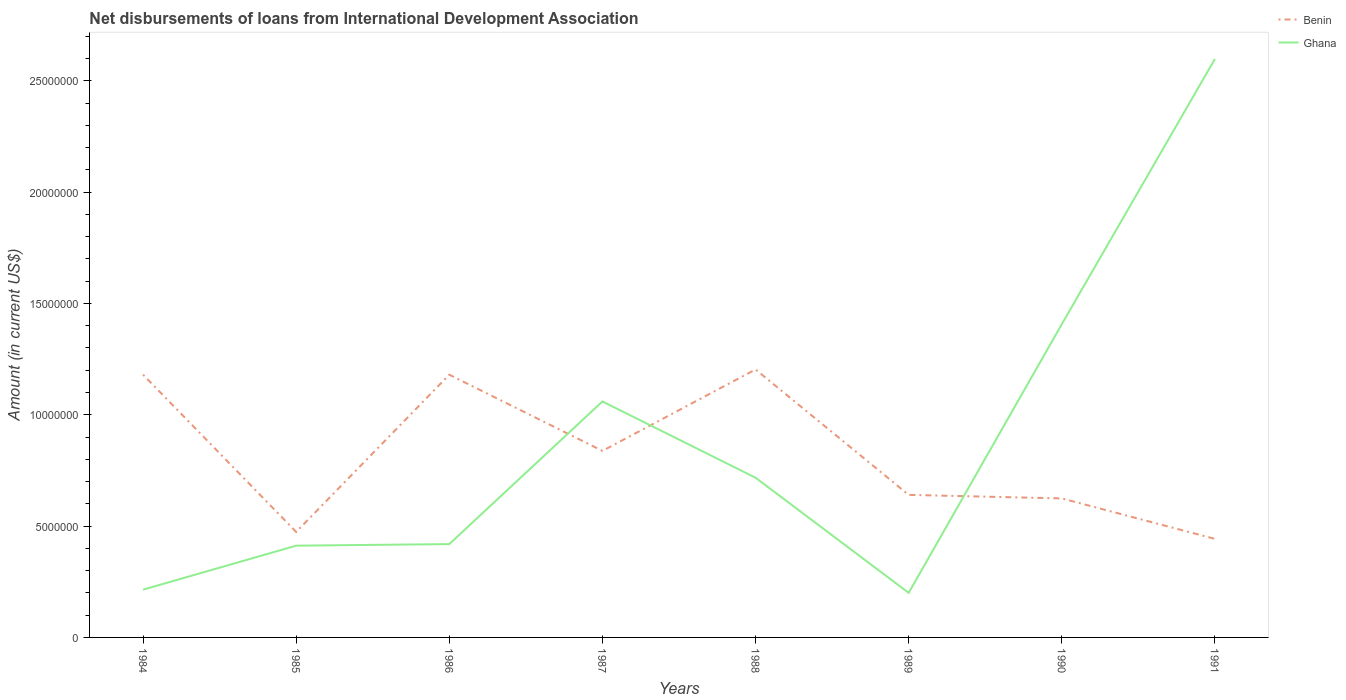Is the number of lines equal to the number of legend labels?
Your response must be concise. Yes. Across all years, what is the maximum amount of loans disbursed in Benin?
Offer a terse response. 4.43e+06. In which year was the amount of loans disbursed in Benin maximum?
Provide a short and direct response. 1991. What is the total amount of loans disbursed in Ghana in the graph?
Give a very brief answer. -1.19e+07. What is the difference between the highest and the second highest amount of loans disbursed in Ghana?
Offer a very short reply. 2.40e+07. What is the difference between the highest and the lowest amount of loans disbursed in Benin?
Keep it short and to the point. 4. Is the amount of loans disbursed in Benin strictly greater than the amount of loans disbursed in Ghana over the years?
Your answer should be compact. No. How many lines are there?
Ensure brevity in your answer.  2. How many years are there in the graph?
Your response must be concise. 8. Does the graph contain any zero values?
Offer a terse response. No. Does the graph contain grids?
Offer a terse response. No. How many legend labels are there?
Keep it short and to the point. 2. How are the legend labels stacked?
Provide a succinct answer. Vertical. What is the title of the graph?
Make the answer very short. Net disbursements of loans from International Development Association. What is the label or title of the X-axis?
Make the answer very short. Years. What is the label or title of the Y-axis?
Your answer should be very brief. Amount (in current US$). What is the Amount (in current US$) in Benin in 1984?
Ensure brevity in your answer.  1.18e+07. What is the Amount (in current US$) of Ghana in 1984?
Ensure brevity in your answer.  2.14e+06. What is the Amount (in current US$) of Benin in 1985?
Make the answer very short. 4.74e+06. What is the Amount (in current US$) of Ghana in 1985?
Make the answer very short. 4.12e+06. What is the Amount (in current US$) in Benin in 1986?
Provide a succinct answer. 1.18e+07. What is the Amount (in current US$) of Ghana in 1986?
Provide a succinct answer. 4.19e+06. What is the Amount (in current US$) of Benin in 1987?
Ensure brevity in your answer.  8.38e+06. What is the Amount (in current US$) in Ghana in 1987?
Make the answer very short. 1.06e+07. What is the Amount (in current US$) of Benin in 1988?
Your answer should be very brief. 1.20e+07. What is the Amount (in current US$) of Ghana in 1988?
Offer a very short reply. 7.17e+06. What is the Amount (in current US$) of Benin in 1989?
Ensure brevity in your answer.  6.40e+06. What is the Amount (in current US$) of Ghana in 1989?
Provide a short and direct response. 2.00e+06. What is the Amount (in current US$) of Benin in 1990?
Give a very brief answer. 6.24e+06. What is the Amount (in current US$) in Ghana in 1990?
Your response must be concise. 1.41e+07. What is the Amount (in current US$) of Benin in 1991?
Provide a succinct answer. 4.43e+06. What is the Amount (in current US$) in Ghana in 1991?
Your answer should be very brief. 2.60e+07. Across all years, what is the maximum Amount (in current US$) in Benin?
Provide a succinct answer. 1.20e+07. Across all years, what is the maximum Amount (in current US$) of Ghana?
Give a very brief answer. 2.60e+07. Across all years, what is the minimum Amount (in current US$) of Benin?
Give a very brief answer. 4.43e+06. Across all years, what is the minimum Amount (in current US$) in Ghana?
Your response must be concise. 2.00e+06. What is the total Amount (in current US$) in Benin in the graph?
Your answer should be compact. 6.58e+07. What is the total Amount (in current US$) of Ghana in the graph?
Your answer should be very brief. 7.03e+07. What is the difference between the Amount (in current US$) of Benin in 1984 and that in 1985?
Give a very brief answer. 7.06e+06. What is the difference between the Amount (in current US$) of Ghana in 1984 and that in 1985?
Your response must be concise. -1.98e+06. What is the difference between the Amount (in current US$) of Benin in 1984 and that in 1986?
Make the answer very short. 2000. What is the difference between the Amount (in current US$) in Ghana in 1984 and that in 1986?
Provide a succinct answer. -2.05e+06. What is the difference between the Amount (in current US$) in Benin in 1984 and that in 1987?
Your answer should be very brief. 3.42e+06. What is the difference between the Amount (in current US$) of Ghana in 1984 and that in 1987?
Make the answer very short. -8.45e+06. What is the difference between the Amount (in current US$) of Benin in 1984 and that in 1988?
Offer a terse response. -2.34e+05. What is the difference between the Amount (in current US$) of Ghana in 1984 and that in 1988?
Your answer should be very brief. -5.03e+06. What is the difference between the Amount (in current US$) in Benin in 1984 and that in 1989?
Keep it short and to the point. 5.40e+06. What is the difference between the Amount (in current US$) in Ghana in 1984 and that in 1989?
Make the answer very short. 1.43e+05. What is the difference between the Amount (in current US$) of Benin in 1984 and that in 1990?
Your answer should be very brief. 5.56e+06. What is the difference between the Amount (in current US$) of Ghana in 1984 and that in 1990?
Your answer should be compact. -1.19e+07. What is the difference between the Amount (in current US$) of Benin in 1984 and that in 1991?
Offer a very short reply. 7.38e+06. What is the difference between the Amount (in current US$) in Ghana in 1984 and that in 1991?
Provide a succinct answer. -2.38e+07. What is the difference between the Amount (in current US$) of Benin in 1985 and that in 1986?
Provide a succinct answer. -7.06e+06. What is the difference between the Amount (in current US$) in Ghana in 1985 and that in 1986?
Give a very brief answer. -7.10e+04. What is the difference between the Amount (in current US$) of Benin in 1985 and that in 1987?
Provide a succinct answer. -3.64e+06. What is the difference between the Amount (in current US$) of Ghana in 1985 and that in 1987?
Your answer should be compact. -6.48e+06. What is the difference between the Amount (in current US$) in Benin in 1985 and that in 1988?
Ensure brevity in your answer.  -7.30e+06. What is the difference between the Amount (in current US$) in Ghana in 1985 and that in 1988?
Ensure brevity in your answer.  -3.05e+06. What is the difference between the Amount (in current US$) in Benin in 1985 and that in 1989?
Provide a succinct answer. -1.66e+06. What is the difference between the Amount (in current US$) of Ghana in 1985 and that in 1989?
Make the answer very short. 2.12e+06. What is the difference between the Amount (in current US$) in Benin in 1985 and that in 1990?
Offer a very short reply. -1.50e+06. What is the difference between the Amount (in current US$) in Ghana in 1985 and that in 1990?
Your answer should be very brief. -9.95e+06. What is the difference between the Amount (in current US$) of Benin in 1985 and that in 1991?
Keep it short and to the point. 3.13e+05. What is the difference between the Amount (in current US$) in Ghana in 1985 and that in 1991?
Offer a terse response. -2.19e+07. What is the difference between the Amount (in current US$) in Benin in 1986 and that in 1987?
Your answer should be compact. 3.42e+06. What is the difference between the Amount (in current US$) of Ghana in 1986 and that in 1987?
Your answer should be compact. -6.41e+06. What is the difference between the Amount (in current US$) in Benin in 1986 and that in 1988?
Provide a succinct answer. -2.36e+05. What is the difference between the Amount (in current US$) in Ghana in 1986 and that in 1988?
Your answer should be very brief. -2.98e+06. What is the difference between the Amount (in current US$) of Benin in 1986 and that in 1989?
Keep it short and to the point. 5.40e+06. What is the difference between the Amount (in current US$) of Ghana in 1986 and that in 1989?
Your answer should be compact. 2.19e+06. What is the difference between the Amount (in current US$) of Benin in 1986 and that in 1990?
Keep it short and to the point. 5.56e+06. What is the difference between the Amount (in current US$) of Ghana in 1986 and that in 1990?
Provide a succinct answer. -9.88e+06. What is the difference between the Amount (in current US$) in Benin in 1986 and that in 1991?
Your answer should be compact. 7.37e+06. What is the difference between the Amount (in current US$) in Ghana in 1986 and that in 1991?
Your answer should be compact. -2.18e+07. What is the difference between the Amount (in current US$) of Benin in 1987 and that in 1988?
Provide a succinct answer. -3.66e+06. What is the difference between the Amount (in current US$) in Ghana in 1987 and that in 1988?
Provide a succinct answer. 3.42e+06. What is the difference between the Amount (in current US$) in Benin in 1987 and that in 1989?
Offer a terse response. 1.98e+06. What is the difference between the Amount (in current US$) of Ghana in 1987 and that in 1989?
Provide a succinct answer. 8.60e+06. What is the difference between the Amount (in current US$) of Benin in 1987 and that in 1990?
Keep it short and to the point. 2.14e+06. What is the difference between the Amount (in current US$) of Ghana in 1987 and that in 1990?
Your answer should be compact. -3.47e+06. What is the difference between the Amount (in current US$) of Benin in 1987 and that in 1991?
Provide a succinct answer. 3.95e+06. What is the difference between the Amount (in current US$) in Ghana in 1987 and that in 1991?
Offer a terse response. -1.54e+07. What is the difference between the Amount (in current US$) in Benin in 1988 and that in 1989?
Offer a terse response. 5.63e+06. What is the difference between the Amount (in current US$) of Ghana in 1988 and that in 1989?
Make the answer very short. 5.17e+06. What is the difference between the Amount (in current US$) of Benin in 1988 and that in 1990?
Give a very brief answer. 5.79e+06. What is the difference between the Amount (in current US$) in Ghana in 1988 and that in 1990?
Provide a short and direct response. -6.90e+06. What is the difference between the Amount (in current US$) in Benin in 1988 and that in 1991?
Offer a terse response. 7.61e+06. What is the difference between the Amount (in current US$) of Ghana in 1988 and that in 1991?
Your answer should be very brief. -1.88e+07. What is the difference between the Amount (in current US$) in Benin in 1989 and that in 1990?
Your answer should be compact. 1.59e+05. What is the difference between the Amount (in current US$) in Ghana in 1989 and that in 1990?
Offer a very short reply. -1.21e+07. What is the difference between the Amount (in current US$) in Benin in 1989 and that in 1991?
Ensure brevity in your answer.  1.98e+06. What is the difference between the Amount (in current US$) of Ghana in 1989 and that in 1991?
Give a very brief answer. -2.40e+07. What is the difference between the Amount (in current US$) in Benin in 1990 and that in 1991?
Provide a succinct answer. 1.82e+06. What is the difference between the Amount (in current US$) of Ghana in 1990 and that in 1991?
Your answer should be very brief. -1.19e+07. What is the difference between the Amount (in current US$) in Benin in 1984 and the Amount (in current US$) in Ghana in 1985?
Your answer should be very brief. 7.68e+06. What is the difference between the Amount (in current US$) of Benin in 1984 and the Amount (in current US$) of Ghana in 1986?
Your response must be concise. 7.61e+06. What is the difference between the Amount (in current US$) in Benin in 1984 and the Amount (in current US$) in Ghana in 1987?
Your answer should be compact. 1.20e+06. What is the difference between the Amount (in current US$) of Benin in 1984 and the Amount (in current US$) of Ghana in 1988?
Ensure brevity in your answer.  4.63e+06. What is the difference between the Amount (in current US$) in Benin in 1984 and the Amount (in current US$) in Ghana in 1989?
Offer a very short reply. 9.80e+06. What is the difference between the Amount (in current US$) of Benin in 1984 and the Amount (in current US$) of Ghana in 1990?
Your answer should be very brief. -2.27e+06. What is the difference between the Amount (in current US$) in Benin in 1984 and the Amount (in current US$) in Ghana in 1991?
Provide a short and direct response. -1.42e+07. What is the difference between the Amount (in current US$) of Benin in 1985 and the Amount (in current US$) of Ghana in 1986?
Your answer should be very brief. 5.47e+05. What is the difference between the Amount (in current US$) of Benin in 1985 and the Amount (in current US$) of Ghana in 1987?
Ensure brevity in your answer.  -5.86e+06. What is the difference between the Amount (in current US$) in Benin in 1985 and the Amount (in current US$) in Ghana in 1988?
Offer a terse response. -2.43e+06. What is the difference between the Amount (in current US$) in Benin in 1985 and the Amount (in current US$) in Ghana in 1989?
Offer a very short reply. 2.74e+06. What is the difference between the Amount (in current US$) of Benin in 1985 and the Amount (in current US$) of Ghana in 1990?
Your answer should be very brief. -9.33e+06. What is the difference between the Amount (in current US$) in Benin in 1985 and the Amount (in current US$) in Ghana in 1991?
Your answer should be very brief. -2.12e+07. What is the difference between the Amount (in current US$) of Benin in 1986 and the Amount (in current US$) of Ghana in 1987?
Ensure brevity in your answer.  1.20e+06. What is the difference between the Amount (in current US$) of Benin in 1986 and the Amount (in current US$) of Ghana in 1988?
Make the answer very short. 4.63e+06. What is the difference between the Amount (in current US$) of Benin in 1986 and the Amount (in current US$) of Ghana in 1989?
Offer a terse response. 9.80e+06. What is the difference between the Amount (in current US$) in Benin in 1986 and the Amount (in current US$) in Ghana in 1990?
Provide a succinct answer. -2.27e+06. What is the difference between the Amount (in current US$) in Benin in 1986 and the Amount (in current US$) in Ghana in 1991?
Your answer should be compact. -1.42e+07. What is the difference between the Amount (in current US$) in Benin in 1987 and the Amount (in current US$) in Ghana in 1988?
Offer a terse response. 1.21e+06. What is the difference between the Amount (in current US$) of Benin in 1987 and the Amount (in current US$) of Ghana in 1989?
Keep it short and to the point. 6.38e+06. What is the difference between the Amount (in current US$) of Benin in 1987 and the Amount (in current US$) of Ghana in 1990?
Your answer should be very brief. -5.69e+06. What is the difference between the Amount (in current US$) in Benin in 1987 and the Amount (in current US$) in Ghana in 1991?
Ensure brevity in your answer.  -1.76e+07. What is the difference between the Amount (in current US$) in Benin in 1988 and the Amount (in current US$) in Ghana in 1989?
Offer a very short reply. 1.00e+07. What is the difference between the Amount (in current US$) of Benin in 1988 and the Amount (in current US$) of Ghana in 1990?
Offer a terse response. -2.03e+06. What is the difference between the Amount (in current US$) of Benin in 1988 and the Amount (in current US$) of Ghana in 1991?
Offer a terse response. -1.39e+07. What is the difference between the Amount (in current US$) in Benin in 1989 and the Amount (in current US$) in Ghana in 1990?
Provide a succinct answer. -7.67e+06. What is the difference between the Amount (in current US$) of Benin in 1989 and the Amount (in current US$) of Ghana in 1991?
Your answer should be very brief. -1.96e+07. What is the difference between the Amount (in current US$) in Benin in 1990 and the Amount (in current US$) in Ghana in 1991?
Offer a terse response. -1.97e+07. What is the average Amount (in current US$) of Benin per year?
Offer a very short reply. 8.23e+06. What is the average Amount (in current US$) in Ghana per year?
Keep it short and to the point. 8.78e+06. In the year 1984, what is the difference between the Amount (in current US$) in Benin and Amount (in current US$) in Ghana?
Offer a terse response. 9.66e+06. In the year 1985, what is the difference between the Amount (in current US$) of Benin and Amount (in current US$) of Ghana?
Your answer should be compact. 6.18e+05. In the year 1986, what is the difference between the Amount (in current US$) of Benin and Amount (in current US$) of Ghana?
Offer a very short reply. 7.61e+06. In the year 1987, what is the difference between the Amount (in current US$) of Benin and Amount (in current US$) of Ghana?
Give a very brief answer. -2.22e+06. In the year 1988, what is the difference between the Amount (in current US$) of Benin and Amount (in current US$) of Ghana?
Provide a succinct answer. 4.86e+06. In the year 1989, what is the difference between the Amount (in current US$) in Benin and Amount (in current US$) in Ghana?
Your answer should be compact. 4.40e+06. In the year 1990, what is the difference between the Amount (in current US$) in Benin and Amount (in current US$) in Ghana?
Your answer should be compact. -7.82e+06. In the year 1991, what is the difference between the Amount (in current US$) in Benin and Amount (in current US$) in Ghana?
Provide a succinct answer. -2.16e+07. What is the ratio of the Amount (in current US$) in Benin in 1984 to that in 1985?
Offer a terse response. 2.49. What is the ratio of the Amount (in current US$) in Ghana in 1984 to that in 1985?
Make the answer very short. 0.52. What is the ratio of the Amount (in current US$) of Benin in 1984 to that in 1986?
Provide a short and direct response. 1. What is the ratio of the Amount (in current US$) in Ghana in 1984 to that in 1986?
Make the answer very short. 0.51. What is the ratio of the Amount (in current US$) in Benin in 1984 to that in 1987?
Provide a succinct answer. 1.41. What is the ratio of the Amount (in current US$) in Ghana in 1984 to that in 1987?
Ensure brevity in your answer.  0.2. What is the ratio of the Amount (in current US$) in Benin in 1984 to that in 1988?
Ensure brevity in your answer.  0.98. What is the ratio of the Amount (in current US$) in Ghana in 1984 to that in 1988?
Provide a short and direct response. 0.3. What is the ratio of the Amount (in current US$) of Benin in 1984 to that in 1989?
Ensure brevity in your answer.  1.84. What is the ratio of the Amount (in current US$) in Ghana in 1984 to that in 1989?
Offer a very short reply. 1.07. What is the ratio of the Amount (in current US$) in Benin in 1984 to that in 1990?
Your answer should be very brief. 1.89. What is the ratio of the Amount (in current US$) in Ghana in 1984 to that in 1990?
Provide a succinct answer. 0.15. What is the ratio of the Amount (in current US$) in Benin in 1984 to that in 1991?
Ensure brevity in your answer.  2.67. What is the ratio of the Amount (in current US$) in Ghana in 1984 to that in 1991?
Ensure brevity in your answer.  0.08. What is the ratio of the Amount (in current US$) in Benin in 1985 to that in 1986?
Your answer should be very brief. 0.4. What is the ratio of the Amount (in current US$) of Ghana in 1985 to that in 1986?
Give a very brief answer. 0.98. What is the ratio of the Amount (in current US$) of Benin in 1985 to that in 1987?
Provide a succinct answer. 0.57. What is the ratio of the Amount (in current US$) in Ghana in 1985 to that in 1987?
Provide a short and direct response. 0.39. What is the ratio of the Amount (in current US$) in Benin in 1985 to that in 1988?
Your response must be concise. 0.39. What is the ratio of the Amount (in current US$) in Ghana in 1985 to that in 1988?
Your answer should be compact. 0.57. What is the ratio of the Amount (in current US$) of Benin in 1985 to that in 1989?
Keep it short and to the point. 0.74. What is the ratio of the Amount (in current US$) of Ghana in 1985 to that in 1989?
Keep it short and to the point. 2.06. What is the ratio of the Amount (in current US$) in Benin in 1985 to that in 1990?
Ensure brevity in your answer.  0.76. What is the ratio of the Amount (in current US$) of Ghana in 1985 to that in 1990?
Your response must be concise. 0.29. What is the ratio of the Amount (in current US$) in Benin in 1985 to that in 1991?
Provide a short and direct response. 1.07. What is the ratio of the Amount (in current US$) in Ghana in 1985 to that in 1991?
Make the answer very short. 0.16. What is the ratio of the Amount (in current US$) of Benin in 1986 to that in 1987?
Provide a succinct answer. 1.41. What is the ratio of the Amount (in current US$) in Ghana in 1986 to that in 1987?
Keep it short and to the point. 0.4. What is the ratio of the Amount (in current US$) of Benin in 1986 to that in 1988?
Offer a very short reply. 0.98. What is the ratio of the Amount (in current US$) in Ghana in 1986 to that in 1988?
Keep it short and to the point. 0.58. What is the ratio of the Amount (in current US$) of Benin in 1986 to that in 1989?
Give a very brief answer. 1.84. What is the ratio of the Amount (in current US$) of Ghana in 1986 to that in 1989?
Give a very brief answer. 2.09. What is the ratio of the Amount (in current US$) of Benin in 1986 to that in 1990?
Your answer should be very brief. 1.89. What is the ratio of the Amount (in current US$) in Ghana in 1986 to that in 1990?
Your response must be concise. 0.3. What is the ratio of the Amount (in current US$) in Benin in 1986 to that in 1991?
Provide a short and direct response. 2.67. What is the ratio of the Amount (in current US$) of Ghana in 1986 to that in 1991?
Give a very brief answer. 0.16. What is the ratio of the Amount (in current US$) of Benin in 1987 to that in 1988?
Make the answer very short. 0.7. What is the ratio of the Amount (in current US$) of Ghana in 1987 to that in 1988?
Your answer should be compact. 1.48. What is the ratio of the Amount (in current US$) in Benin in 1987 to that in 1989?
Keep it short and to the point. 1.31. What is the ratio of the Amount (in current US$) in Ghana in 1987 to that in 1989?
Provide a succinct answer. 5.29. What is the ratio of the Amount (in current US$) in Benin in 1987 to that in 1990?
Offer a very short reply. 1.34. What is the ratio of the Amount (in current US$) in Ghana in 1987 to that in 1990?
Offer a terse response. 0.75. What is the ratio of the Amount (in current US$) in Benin in 1987 to that in 1991?
Ensure brevity in your answer.  1.89. What is the ratio of the Amount (in current US$) of Ghana in 1987 to that in 1991?
Offer a terse response. 0.41. What is the ratio of the Amount (in current US$) of Benin in 1988 to that in 1989?
Keep it short and to the point. 1.88. What is the ratio of the Amount (in current US$) of Ghana in 1988 to that in 1989?
Your answer should be very brief. 3.58. What is the ratio of the Amount (in current US$) in Benin in 1988 to that in 1990?
Keep it short and to the point. 1.93. What is the ratio of the Amount (in current US$) of Ghana in 1988 to that in 1990?
Your answer should be compact. 0.51. What is the ratio of the Amount (in current US$) in Benin in 1988 to that in 1991?
Your answer should be very brief. 2.72. What is the ratio of the Amount (in current US$) in Ghana in 1988 to that in 1991?
Ensure brevity in your answer.  0.28. What is the ratio of the Amount (in current US$) in Benin in 1989 to that in 1990?
Offer a very short reply. 1.03. What is the ratio of the Amount (in current US$) in Ghana in 1989 to that in 1990?
Your response must be concise. 0.14. What is the ratio of the Amount (in current US$) of Benin in 1989 to that in 1991?
Keep it short and to the point. 1.45. What is the ratio of the Amount (in current US$) in Ghana in 1989 to that in 1991?
Ensure brevity in your answer.  0.08. What is the ratio of the Amount (in current US$) in Benin in 1990 to that in 1991?
Offer a very short reply. 1.41. What is the ratio of the Amount (in current US$) in Ghana in 1990 to that in 1991?
Offer a very short reply. 0.54. What is the difference between the highest and the second highest Amount (in current US$) of Benin?
Offer a terse response. 2.34e+05. What is the difference between the highest and the second highest Amount (in current US$) of Ghana?
Provide a succinct answer. 1.19e+07. What is the difference between the highest and the lowest Amount (in current US$) of Benin?
Offer a very short reply. 7.61e+06. What is the difference between the highest and the lowest Amount (in current US$) in Ghana?
Give a very brief answer. 2.40e+07. 